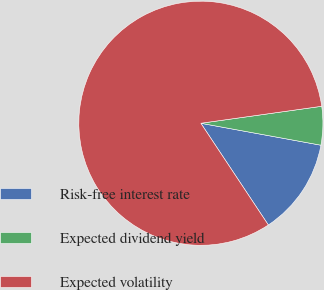Convert chart. <chart><loc_0><loc_0><loc_500><loc_500><pie_chart><fcel>Risk-free interest rate<fcel>Expected dividend yield<fcel>Expected volatility<nl><fcel>12.8%<fcel>5.1%<fcel>82.1%<nl></chart> 